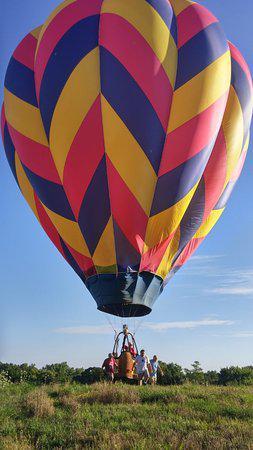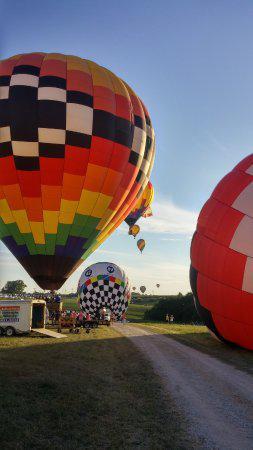The first image is the image on the left, the second image is the image on the right. Assess this claim about the two images: "The left image features at least one but no more than two hot air balloons in the air a distance from the ground, and the right image includes a hot air balloon that is not in the air.". Correct or not? Answer yes or no. No. 